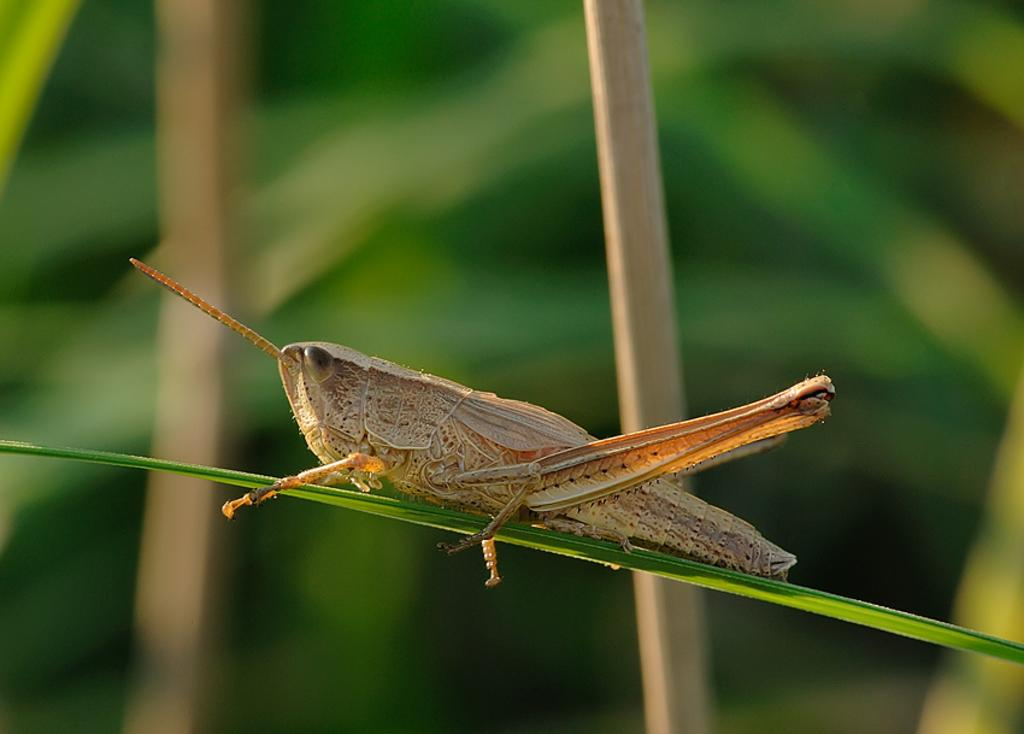What is the condition of the background in the image? The background portion of the picture is blurred. What type of insect can be seen in the image? There is a grasshopper in the image. Where is the grasshopper located? The grasshopper is on a leaf. How does the grasshopper apply the brake while on the leaf in the image? There are no brakes present in the image, as grasshoppers do not have brakes. The grasshopper is simply resting on the leaf. 